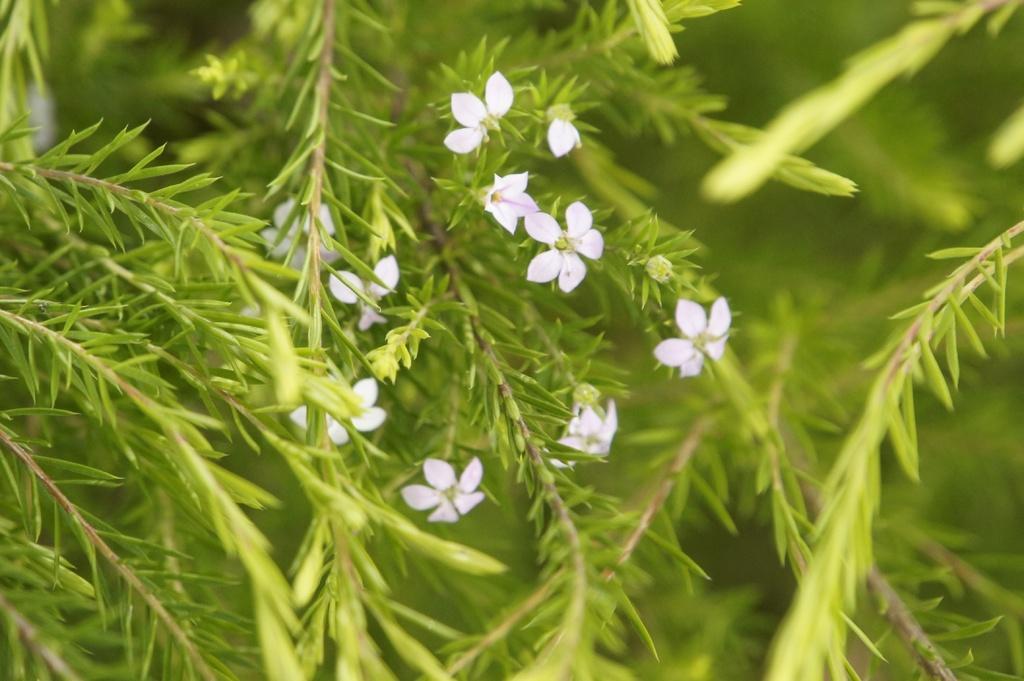Could you give a brief overview of what you see in this image? In this image I can see some flowers to the plant. These flowers are in white color and the plant is in green color. 